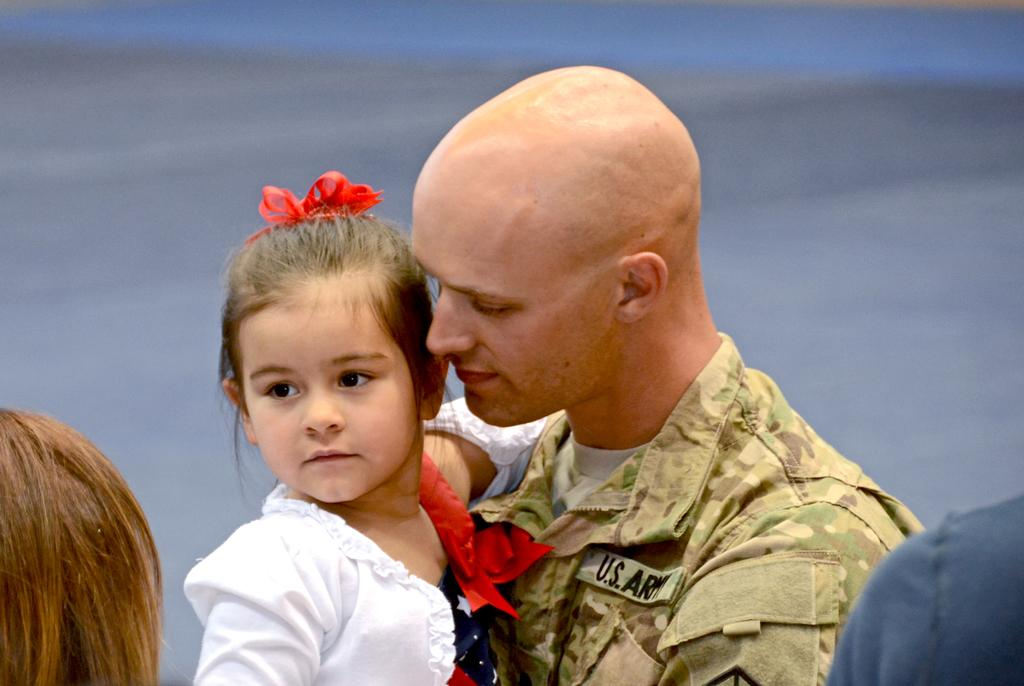How many people are present in the image? There are four people in the image. What can be observed about the attire of two of the people? Two people are wearing different color dresses. Can you describe the clothing of one of the individuals? One person is wearing a military dress. What type of key is being used by one of the people in the image? There is no key present in the image; it only features four people, with two wearing different color dresses and one wearing a military dress. 